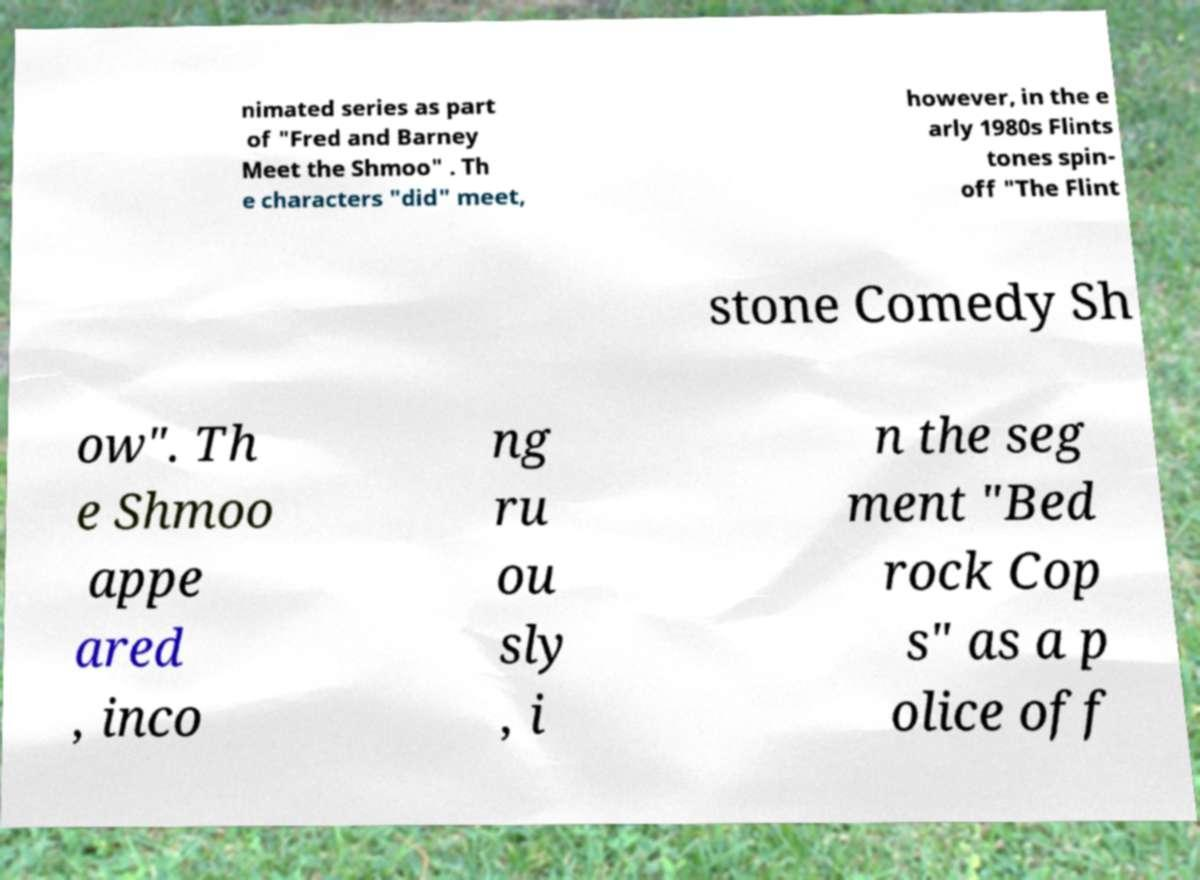For documentation purposes, I need the text within this image transcribed. Could you provide that? nimated series as part of "Fred and Barney Meet the Shmoo" . Th e characters "did" meet, however, in the e arly 1980s Flints tones spin- off "The Flint stone Comedy Sh ow". Th e Shmoo appe ared , inco ng ru ou sly , i n the seg ment "Bed rock Cop s" as a p olice off 